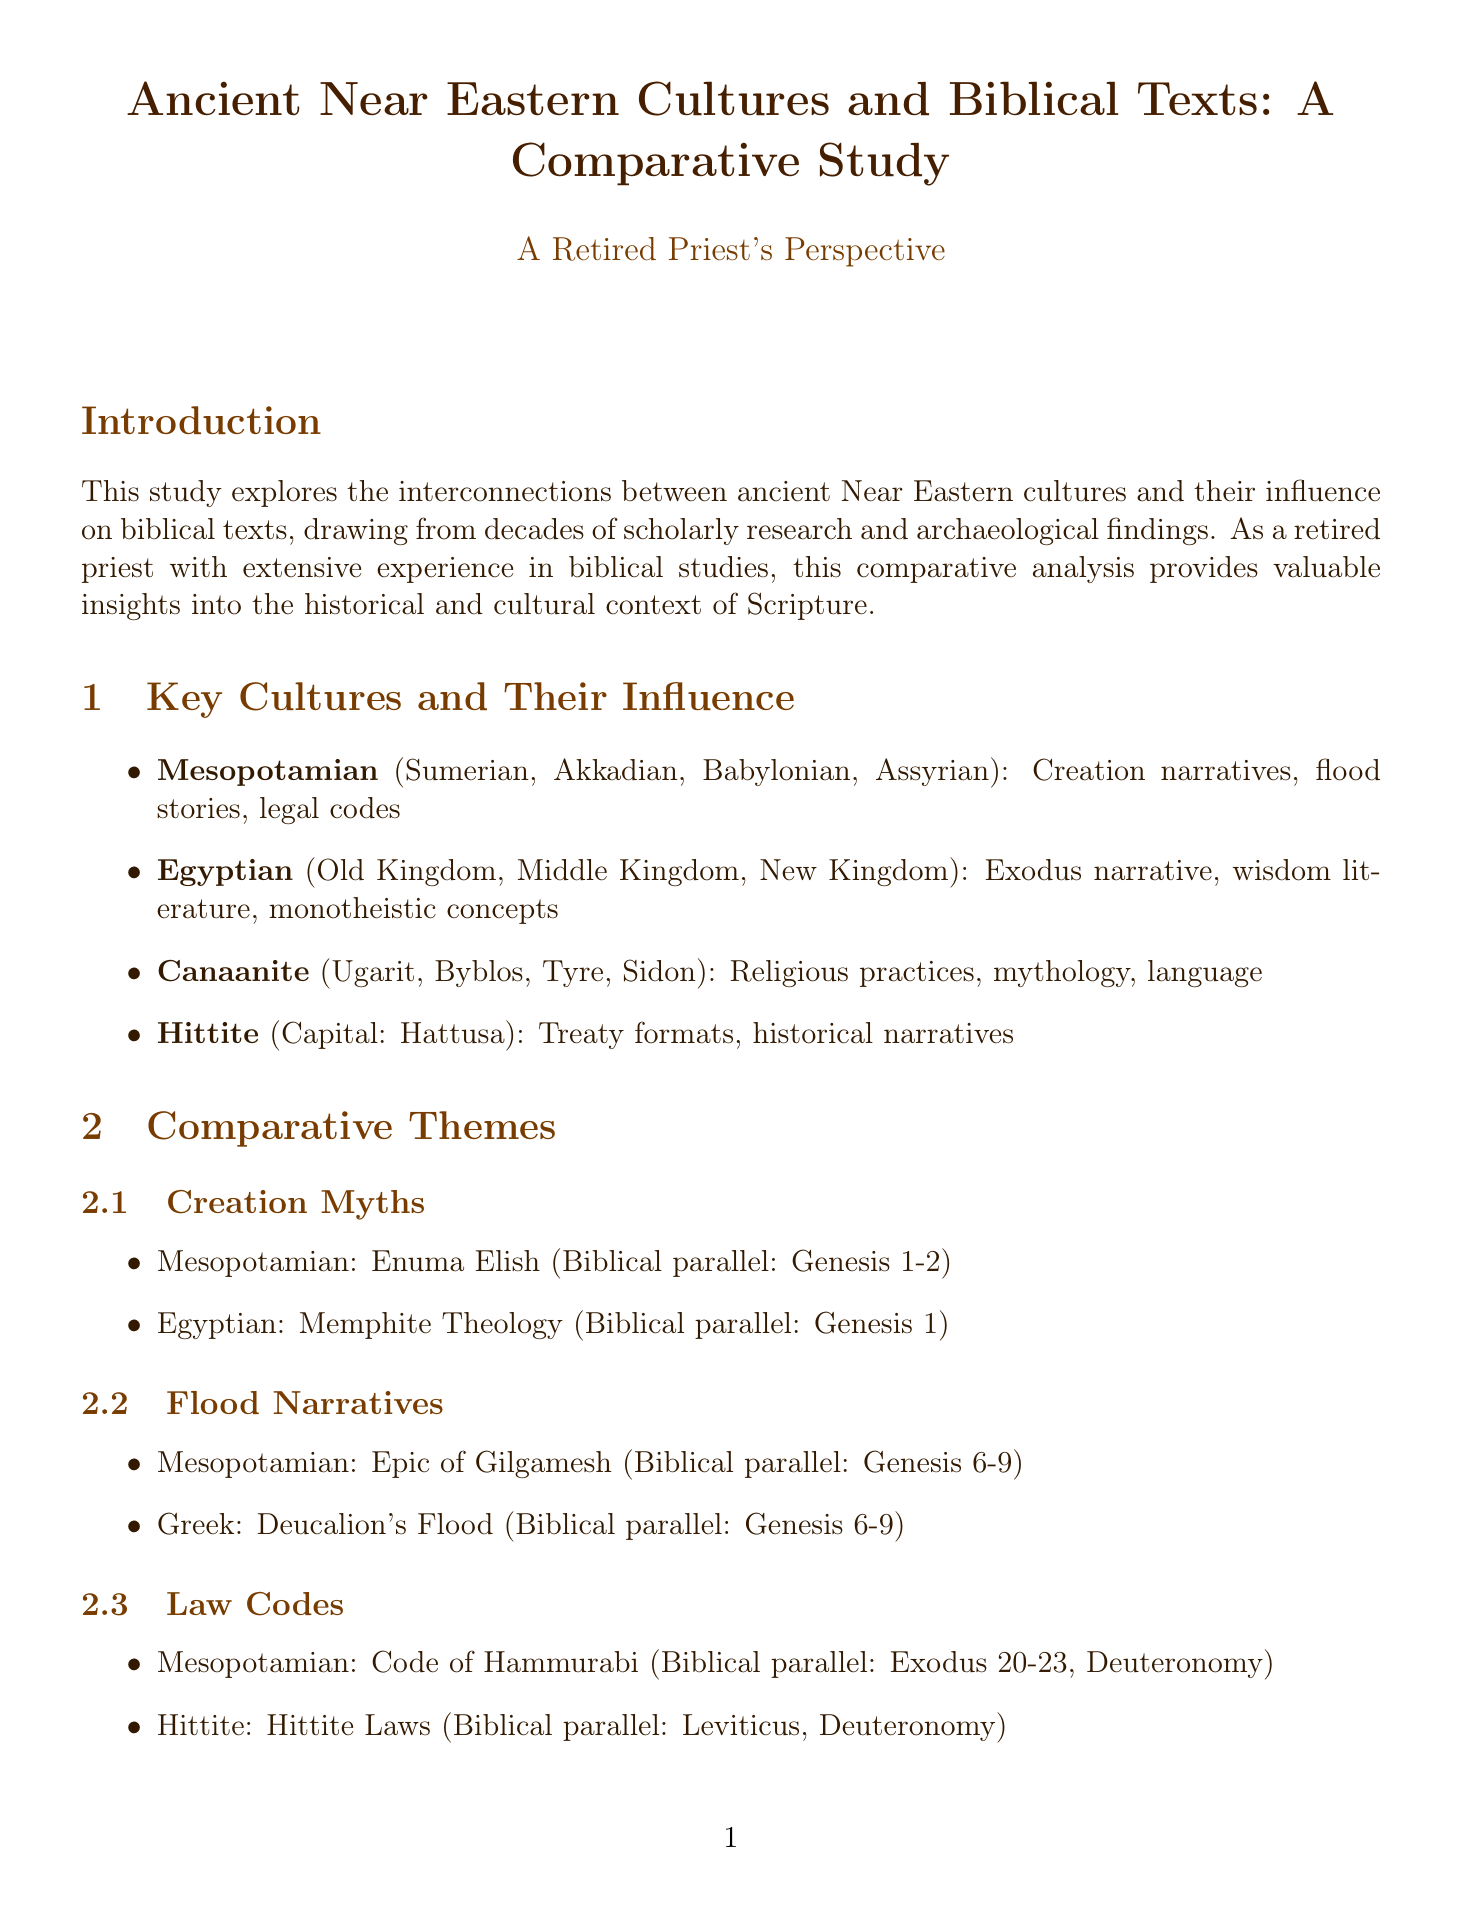What are the key regions discussed in the document? The key regions are specified under the "Regions and Cities of the Ancient Near East" section, which lists Mesopotamia, Egypt, Canaan, Anatolia (Hittite Empire), and Persia.
Answer: Mesopotamia, Egypt, Canaan, Anatolia (Hittite Empire), Persia Who are the authors of "The Bible Unearthed"? This information is found in the "Scholarly Resources" section, detailing the authors of the specified book as Israel Finkelstein and Neil Asher Silberman.
Answer: Israel Finkelstein, Neil Asher Silberman What narrative is paired with the Code of Hammurabi in the comparative themes? The connection is mentioned in the "Law Codes" section of the Comparative Themes, associating the Code of Hammurabi with the biblical parallels in Exodus and Deuteronomy.
Answer: Exodus 20-23, Deuteronomy What event is dated to c. 586 BCE? The "Key Events in Ancient Near Eastern and Biblical Chronology" section specifies the event of the destruction of the First Temple and the Babylonian Exile occurring in that year.
Answer: Destruction of First Temple, Babylonian Exile Which culture is associated with the text "Enuma Elish"? In the "Creation Myths" subsection, it is noted that this text is from the Mesopotamian culture, highlighting its relevance to biblical creation accounts.
Answer: Mesopotamian What influence did the Canaanite culture have on biblical texts? The influence of the Canaanite culture is outlined in the "Key Cultures and Their Influence" section, emphasizing aspects such as religious practices and mythology.
Answer: Religious practices, mythology, language What is the title of the document? The title is stated at the beginning of the document, specifically referencing the focus on ancient Near Eastern cultures and biblical texts.
Answer: Ancient Near Eastern Cultures and Biblical Texts: A Comparative Study What scholarly resource discusses ancient Near Eastern thought? The "Scholarly Resources" section lists John H. Walton's work that introduces the conceptual world of the Hebrew Bible.
Answer: Ancient Near Eastern Thought and the Old Testament 